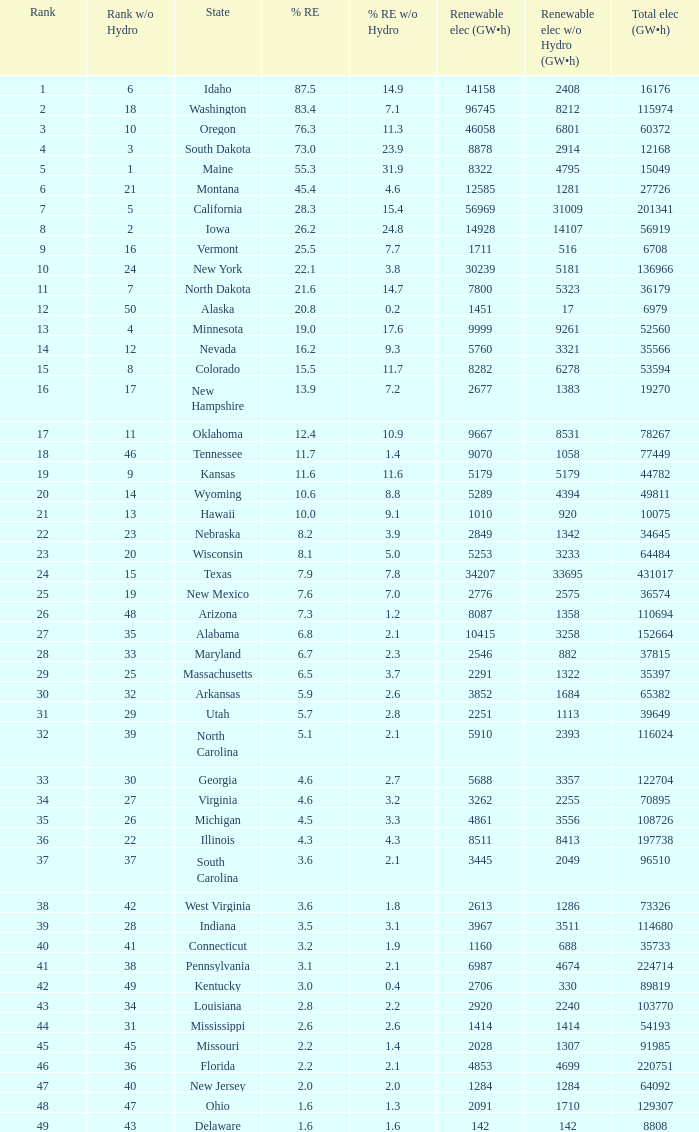What is the amount of renewable electricity without hydrogen power when the percentage of renewable energy is 83.4? 8212.0. 